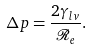Convert formula to latex. <formula><loc_0><loc_0><loc_500><loc_500>\Delta p = \frac { 2 \gamma _ { l v } } { \mathcal { R } _ { e } } .</formula> 